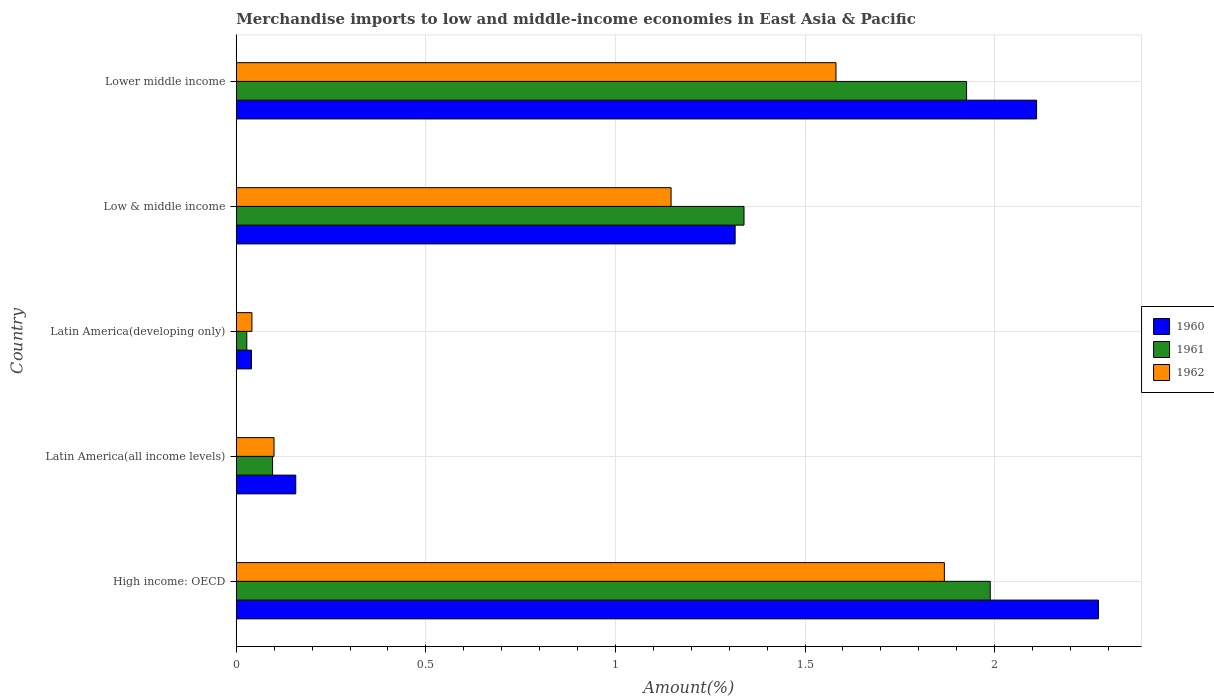How many groups of bars are there?
Ensure brevity in your answer.  5. Are the number of bars on each tick of the Y-axis equal?
Provide a short and direct response. Yes. How many bars are there on the 2nd tick from the top?
Provide a succinct answer. 3. How many bars are there on the 5th tick from the bottom?
Your answer should be compact. 3. What is the label of the 5th group of bars from the top?
Your answer should be compact. High income: OECD. What is the percentage of amount earned from merchandise imports in 1962 in Latin America(all income levels)?
Provide a short and direct response. 0.1. Across all countries, what is the maximum percentage of amount earned from merchandise imports in 1962?
Give a very brief answer. 1.87. Across all countries, what is the minimum percentage of amount earned from merchandise imports in 1962?
Provide a succinct answer. 0.04. In which country was the percentage of amount earned from merchandise imports in 1962 maximum?
Offer a terse response. High income: OECD. In which country was the percentage of amount earned from merchandise imports in 1961 minimum?
Provide a succinct answer. Latin America(developing only). What is the total percentage of amount earned from merchandise imports in 1961 in the graph?
Provide a short and direct response. 5.38. What is the difference between the percentage of amount earned from merchandise imports in 1960 in Latin America(developing only) and that in Lower middle income?
Provide a short and direct response. -2.07. What is the difference between the percentage of amount earned from merchandise imports in 1961 in High income: OECD and the percentage of amount earned from merchandise imports in 1960 in Latin America(developing only)?
Provide a succinct answer. 1.95. What is the average percentage of amount earned from merchandise imports in 1960 per country?
Ensure brevity in your answer.  1.18. What is the difference between the percentage of amount earned from merchandise imports in 1960 and percentage of amount earned from merchandise imports in 1962 in Latin America(all income levels)?
Keep it short and to the point. 0.06. What is the ratio of the percentage of amount earned from merchandise imports in 1962 in High income: OECD to that in Latin America(all income levels)?
Keep it short and to the point. 18.75. Is the percentage of amount earned from merchandise imports in 1962 in Latin America(all income levels) less than that in Latin America(developing only)?
Provide a succinct answer. No. What is the difference between the highest and the second highest percentage of amount earned from merchandise imports in 1962?
Your answer should be compact. 0.29. What is the difference between the highest and the lowest percentage of amount earned from merchandise imports in 1962?
Provide a short and direct response. 1.83. In how many countries, is the percentage of amount earned from merchandise imports in 1960 greater than the average percentage of amount earned from merchandise imports in 1960 taken over all countries?
Your response must be concise. 3. Is the sum of the percentage of amount earned from merchandise imports in 1962 in Latin America(all income levels) and Low & middle income greater than the maximum percentage of amount earned from merchandise imports in 1961 across all countries?
Make the answer very short. No. What does the 2nd bar from the bottom in Latin America(developing only) represents?
Offer a terse response. 1961. How many bars are there?
Provide a short and direct response. 15. How many countries are there in the graph?
Make the answer very short. 5. How many legend labels are there?
Make the answer very short. 3. What is the title of the graph?
Your answer should be very brief. Merchandise imports to low and middle-income economies in East Asia & Pacific. Does "1972" appear as one of the legend labels in the graph?
Ensure brevity in your answer.  No. What is the label or title of the X-axis?
Keep it short and to the point. Amount(%). What is the Amount(%) of 1960 in High income: OECD?
Offer a terse response. 2.27. What is the Amount(%) in 1961 in High income: OECD?
Your answer should be very brief. 1.99. What is the Amount(%) of 1962 in High income: OECD?
Offer a terse response. 1.87. What is the Amount(%) in 1960 in Latin America(all income levels)?
Provide a succinct answer. 0.16. What is the Amount(%) of 1961 in Latin America(all income levels)?
Provide a short and direct response. 0.1. What is the Amount(%) of 1962 in Latin America(all income levels)?
Provide a succinct answer. 0.1. What is the Amount(%) in 1960 in Latin America(developing only)?
Make the answer very short. 0.04. What is the Amount(%) of 1961 in Latin America(developing only)?
Your answer should be very brief. 0.03. What is the Amount(%) in 1962 in Latin America(developing only)?
Provide a short and direct response. 0.04. What is the Amount(%) of 1960 in Low & middle income?
Your answer should be compact. 1.32. What is the Amount(%) of 1961 in Low & middle income?
Provide a succinct answer. 1.34. What is the Amount(%) in 1962 in Low & middle income?
Offer a very short reply. 1.15. What is the Amount(%) of 1960 in Lower middle income?
Your answer should be compact. 2.11. What is the Amount(%) in 1961 in Lower middle income?
Provide a succinct answer. 1.93. What is the Amount(%) in 1962 in Lower middle income?
Provide a succinct answer. 1.58. Across all countries, what is the maximum Amount(%) of 1960?
Your answer should be compact. 2.27. Across all countries, what is the maximum Amount(%) in 1961?
Make the answer very short. 1.99. Across all countries, what is the maximum Amount(%) of 1962?
Provide a short and direct response. 1.87. Across all countries, what is the minimum Amount(%) in 1960?
Offer a very short reply. 0.04. Across all countries, what is the minimum Amount(%) of 1961?
Your answer should be very brief. 0.03. Across all countries, what is the minimum Amount(%) in 1962?
Provide a short and direct response. 0.04. What is the total Amount(%) of 1960 in the graph?
Make the answer very short. 5.9. What is the total Amount(%) of 1961 in the graph?
Give a very brief answer. 5.38. What is the total Amount(%) of 1962 in the graph?
Your answer should be compact. 4.74. What is the difference between the Amount(%) of 1960 in High income: OECD and that in Latin America(all income levels)?
Make the answer very short. 2.12. What is the difference between the Amount(%) in 1961 in High income: OECD and that in Latin America(all income levels)?
Provide a succinct answer. 1.89. What is the difference between the Amount(%) of 1962 in High income: OECD and that in Latin America(all income levels)?
Give a very brief answer. 1.77. What is the difference between the Amount(%) of 1960 in High income: OECD and that in Latin America(developing only)?
Give a very brief answer. 2.23. What is the difference between the Amount(%) of 1961 in High income: OECD and that in Latin America(developing only)?
Your response must be concise. 1.96. What is the difference between the Amount(%) in 1962 in High income: OECD and that in Latin America(developing only)?
Your answer should be very brief. 1.83. What is the difference between the Amount(%) in 1960 in High income: OECD and that in Low & middle income?
Provide a succinct answer. 0.96. What is the difference between the Amount(%) in 1961 in High income: OECD and that in Low & middle income?
Provide a short and direct response. 0.65. What is the difference between the Amount(%) of 1962 in High income: OECD and that in Low & middle income?
Your answer should be very brief. 0.72. What is the difference between the Amount(%) of 1960 in High income: OECD and that in Lower middle income?
Provide a short and direct response. 0.16. What is the difference between the Amount(%) of 1961 in High income: OECD and that in Lower middle income?
Your answer should be compact. 0.06. What is the difference between the Amount(%) of 1962 in High income: OECD and that in Lower middle income?
Ensure brevity in your answer.  0.29. What is the difference between the Amount(%) of 1960 in Latin America(all income levels) and that in Latin America(developing only)?
Give a very brief answer. 0.12. What is the difference between the Amount(%) of 1961 in Latin America(all income levels) and that in Latin America(developing only)?
Provide a short and direct response. 0.07. What is the difference between the Amount(%) of 1962 in Latin America(all income levels) and that in Latin America(developing only)?
Keep it short and to the point. 0.06. What is the difference between the Amount(%) in 1960 in Latin America(all income levels) and that in Low & middle income?
Offer a terse response. -1.16. What is the difference between the Amount(%) of 1961 in Latin America(all income levels) and that in Low & middle income?
Provide a succinct answer. -1.24. What is the difference between the Amount(%) of 1962 in Latin America(all income levels) and that in Low & middle income?
Make the answer very short. -1.05. What is the difference between the Amount(%) in 1960 in Latin America(all income levels) and that in Lower middle income?
Provide a short and direct response. -1.95. What is the difference between the Amount(%) of 1961 in Latin America(all income levels) and that in Lower middle income?
Provide a succinct answer. -1.83. What is the difference between the Amount(%) in 1962 in Latin America(all income levels) and that in Lower middle income?
Provide a succinct answer. -1.48. What is the difference between the Amount(%) of 1960 in Latin America(developing only) and that in Low & middle income?
Your answer should be compact. -1.28. What is the difference between the Amount(%) of 1961 in Latin America(developing only) and that in Low & middle income?
Give a very brief answer. -1.31. What is the difference between the Amount(%) of 1962 in Latin America(developing only) and that in Low & middle income?
Your answer should be very brief. -1.11. What is the difference between the Amount(%) of 1960 in Latin America(developing only) and that in Lower middle income?
Provide a short and direct response. -2.07. What is the difference between the Amount(%) in 1961 in Latin America(developing only) and that in Lower middle income?
Give a very brief answer. -1.9. What is the difference between the Amount(%) in 1962 in Latin America(developing only) and that in Lower middle income?
Your answer should be very brief. -1.54. What is the difference between the Amount(%) in 1960 in Low & middle income and that in Lower middle income?
Ensure brevity in your answer.  -0.8. What is the difference between the Amount(%) of 1961 in Low & middle income and that in Lower middle income?
Offer a very short reply. -0.59. What is the difference between the Amount(%) in 1962 in Low & middle income and that in Lower middle income?
Offer a terse response. -0.43. What is the difference between the Amount(%) of 1960 in High income: OECD and the Amount(%) of 1961 in Latin America(all income levels)?
Provide a succinct answer. 2.18. What is the difference between the Amount(%) in 1960 in High income: OECD and the Amount(%) in 1962 in Latin America(all income levels)?
Ensure brevity in your answer.  2.17. What is the difference between the Amount(%) in 1961 in High income: OECD and the Amount(%) in 1962 in Latin America(all income levels)?
Your response must be concise. 1.89. What is the difference between the Amount(%) in 1960 in High income: OECD and the Amount(%) in 1961 in Latin America(developing only)?
Provide a succinct answer. 2.25. What is the difference between the Amount(%) of 1960 in High income: OECD and the Amount(%) of 1962 in Latin America(developing only)?
Offer a terse response. 2.23. What is the difference between the Amount(%) of 1961 in High income: OECD and the Amount(%) of 1962 in Latin America(developing only)?
Your answer should be compact. 1.95. What is the difference between the Amount(%) of 1960 in High income: OECD and the Amount(%) of 1961 in Low & middle income?
Your answer should be very brief. 0.93. What is the difference between the Amount(%) of 1960 in High income: OECD and the Amount(%) of 1962 in Low & middle income?
Provide a succinct answer. 1.13. What is the difference between the Amount(%) of 1961 in High income: OECD and the Amount(%) of 1962 in Low & middle income?
Your answer should be very brief. 0.84. What is the difference between the Amount(%) in 1960 in High income: OECD and the Amount(%) in 1961 in Lower middle income?
Your response must be concise. 0.35. What is the difference between the Amount(%) in 1960 in High income: OECD and the Amount(%) in 1962 in Lower middle income?
Provide a short and direct response. 0.69. What is the difference between the Amount(%) in 1961 in High income: OECD and the Amount(%) in 1962 in Lower middle income?
Give a very brief answer. 0.41. What is the difference between the Amount(%) in 1960 in Latin America(all income levels) and the Amount(%) in 1961 in Latin America(developing only)?
Your answer should be compact. 0.13. What is the difference between the Amount(%) of 1960 in Latin America(all income levels) and the Amount(%) of 1962 in Latin America(developing only)?
Your response must be concise. 0.12. What is the difference between the Amount(%) in 1961 in Latin America(all income levels) and the Amount(%) in 1962 in Latin America(developing only)?
Give a very brief answer. 0.05. What is the difference between the Amount(%) of 1960 in Latin America(all income levels) and the Amount(%) of 1961 in Low & middle income?
Your response must be concise. -1.18. What is the difference between the Amount(%) in 1960 in Latin America(all income levels) and the Amount(%) in 1962 in Low & middle income?
Your answer should be compact. -0.99. What is the difference between the Amount(%) of 1961 in Latin America(all income levels) and the Amount(%) of 1962 in Low & middle income?
Your response must be concise. -1.05. What is the difference between the Amount(%) in 1960 in Latin America(all income levels) and the Amount(%) in 1961 in Lower middle income?
Your answer should be very brief. -1.77. What is the difference between the Amount(%) in 1960 in Latin America(all income levels) and the Amount(%) in 1962 in Lower middle income?
Give a very brief answer. -1.42. What is the difference between the Amount(%) in 1961 in Latin America(all income levels) and the Amount(%) in 1962 in Lower middle income?
Your response must be concise. -1.49. What is the difference between the Amount(%) of 1960 in Latin America(developing only) and the Amount(%) of 1961 in Low & middle income?
Make the answer very short. -1.3. What is the difference between the Amount(%) of 1960 in Latin America(developing only) and the Amount(%) of 1962 in Low & middle income?
Make the answer very short. -1.11. What is the difference between the Amount(%) of 1961 in Latin America(developing only) and the Amount(%) of 1962 in Low & middle income?
Offer a very short reply. -1.12. What is the difference between the Amount(%) in 1960 in Latin America(developing only) and the Amount(%) in 1961 in Lower middle income?
Your response must be concise. -1.89. What is the difference between the Amount(%) in 1960 in Latin America(developing only) and the Amount(%) in 1962 in Lower middle income?
Ensure brevity in your answer.  -1.54. What is the difference between the Amount(%) in 1961 in Latin America(developing only) and the Amount(%) in 1962 in Lower middle income?
Offer a terse response. -1.55. What is the difference between the Amount(%) of 1960 in Low & middle income and the Amount(%) of 1961 in Lower middle income?
Give a very brief answer. -0.61. What is the difference between the Amount(%) of 1960 in Low & middle income and the Amount(%) of 1962 in Lower middle income?
Your response must be concise. -0.27. What is the difference between the Amount(%) of 1961 in Low & middle income and the Amount(%) of 1962 in Lower middle income?
Provide a succinct answer. -0.24. What is the average Amount(%) of 1960 per country?
Give a very brief answer. 1.18. What is the average Amount(%) of 1961 per country?
Offer a very short reply. 1.08. What is the average Amount(%) of 1962 per country?
Offer a very short reply. 0.95. What is the difference between the Amount(%) in 1960 and Amount(%) in 1961 in High income: OECD?
Offer a very short reply. 0.29. What is the difference between the Amount(%) of 1960 and Amount(%) of 1962 in High income: OECD?
Provide a succinct answer. 0.41. What is the difference between the Amount(%) in 1961 and Amount(%) in 1962 in High income: OECD?
Give a very brief answer. 0.12. What is the difference between the Amount(%) of 1960 and Amount(%) of 1961 in Latin America(all income levels)?
Your response must be concise. 0.06. What is the difference between the Amount(%) of 1960 and Amount(%) of 1962 in Latin America(all income levels)?
Your answer should be very brief. 0.06. What is the difference between the Amount(%) in 1961 and Amount(%) in 1962 in Latin America(all income levels)?
Provide a succinct answer. -0. What is the difference between the Amount(%) of 1960 and Amount(%) of 1961 in Latin America(developing only)?
Your response must be concise. 0.01. What is the difference between the Amount(%) in 1960 and Amount(%) in 1962 in Latin America(developing only)?
Offer a very short reply. -0. What is the difference between the Amount(%) of 1961 and Amount(%) of 1962 in Latin America(developing only)?
Offer a very short reply. -0.01. What is the difference between the Amount(%) of 1960 and Amount(%) of 1961 in Low & middle income?
Make the answer very short. -0.02. What is the difference between the Amount(%) in 1960 and Amount(%) in 1962 in Low & middle income?
Provide a short and direct response. 0.17. What is the difference between the Amount(%) in 1961 and Amount(%) in 1962 in Low & middle income?
Provide a short and direct response. 0.19. What is the difference between the Amount(%) of 1960 and Amount(%) of 1961 in Lower middle income?
Your response must be concise. 0.18. What is the difference between the Amount(%) in 1960 and Amount(%) in 1962 in Lower middle income?
Ensure brevity in your answer.  0.53. What is the difference between the Amount(%) in 1961 and Amount(%) in 1962 in Lower middle income?
Ensure brevity in your answer.  0.34. What is the ratio of the Amount(%) in 1960 in High income: OECD to that in Latin America(all income levels)?
Offer a terse response. 14.49. What is the ratio of the Amount(%) in 1961 in High income: OECD to that in Latin America(all income levels)?
Your answer should be very brief. 20.76. What is the ratio of the Amount(%) of 1962 in High income: OECD to that in Latin America(all income levels)?
Give a very brief answer. 18.75. What is the ratio of the Amount(%) of 1960 in High income: OECD to that in Latin America(developing only)?
Give a very brief answer. 56.7. What is the ratio of the Amount(%) of 1961 in High income: OECD to that in Latin America(developing only)?
Your response must be concise. 71.56. What is the ratio of the Amount(%) in 1962 in High income: OECD to that in Latin America(developing only)?
Provide a short and direct response. 45.19. What is the ratio of the Amount(%) of 1960 in High income: OECD to that in Low & middle income?
Offer a very short reply. 1.73. What is the ratio of the Amount(%) of 1961 in High income: OECD to that in Low & middle income?
Your response must be concise. 1.48. What is the ratio of the Amount(%) in 1962 in High income: OECD to that in Low & middle income?
Your answer should be very brief. 1.63. What is the ratio of the Amount(%) of 1960 in High income: OECD to that in Lower middle income?
Offer a terse response. 1.08. What is the ratio of the Amount(%) in 1961 in High income: OECD to that in Lower middle income?
Ensure brevity in your answer.  1.03. What is the ratio of the Amount(%) in 1962 in High income: OECD to that in Lower middle income?
Make the answer very short. 1.18. What is the ratio of the Amount(%) of 1960 in Latin America(all income levels) to that in Latin America(developing only)?
Your answer should be very brief. 3.91. What is the ratio of the Amount(%) in 1961 in Latin America(all income levels) to that in Latin America(developing only)?
Provide a short and direct response. 3.45. What is the ratio of the Amount(%) of 1962 in Latin America(all income levels) to that in Latin America(developing only)?
Keep it short and to the point. 2.41. What is the ratio of the Amount(%) of 1960 in Latin America(all income levels) to that in Low & middle income?
Give a very brief answer. 0.12. What is the ratio of the Amount(%) in 1961 in Latin America(all income levels) to that in Low & middle income?
Provide a succinct answer. 0.07. What is the ratio of the Amount(%) of 1962 in Latin America(all income levels) to that in Low & middle income?
Keep it short and to the point. 0.09. What is the ratio of the Amount(%) of 1960 in Latin America(all income levels) to that in Lower middle income?
Your answer should be very brief. 0.07. What is the ratio of the Amount(%) in 1961 in Latin America(all income levels) to that in Lower middle income?
Provide a succinct answer. 0.05. What is the ratio of the Amount(%) in 1962 in Latin America(all income levels) to that in Lower middle income?
Provide a succinct answer. 0.06. What is the ratio of the Amount(%) of 1960 in Latin America(developing only) to that in Low & middle income?
Your response must be concise. 0.03. What is the ratio of the Amount(%) of 1961 in Latin America(developing only) to that in Low & middle income?
Your answer should be very brief. 0.02. What is the ratio of the Amount(%) of 1962 in Latin America(developing only) to that in Low & middle income?
Offer a very short reply. 0.04. What is the ratio of the Amount(%) in 1960 in Latin America(developing only) to that in Lower middle income?
Offer a terse response. 0.02. What is the ratio of the Amount(%) in 1961 in Latin America(developing only) to that in Lower middle income?
Make the answer very short. 0.01. What is the ratio of the Amount(%) of 1962 in Latin America(developing only) to that in Lower middle income?
Provide a short and direct response. 0.03. What is the ratio of the Amount(%) in 1960 in Low & middle income to that in Lower middle income?
Your response must be concise. 0.62. What is the ratio of the Amount(%) in 1961 in Low & middle income to that in Lower middle income?
Give a very brief answer. 0.7. What is the ratio of the Amount(%) in 1962 in Low & middle income to that in Lower middle income?
Your answer should be very brief. 0.73. What is the difference between the highest and the second highest Amount(%) in 1960?
Provide a short and direct response. 0.16. What is the difference between the highest and the second highest Amount(%) in 1961?
Make the answer very short. 0.06. What is the difference between the highest and the second highest Amount(%) in 1962?
Offer a very short reply. 0.29. What is the difference between the highest and the lowest Amount(%) of 1960?
Provide a short and direct response. 2.23. What is the difference between the highest and the lowest Amount(%) in 1961?
Your answer should be compact. 1.96. What is the difference between the highest and the lowest Amount(%) in 1962?
Provide a succinct answer. 1.83. 